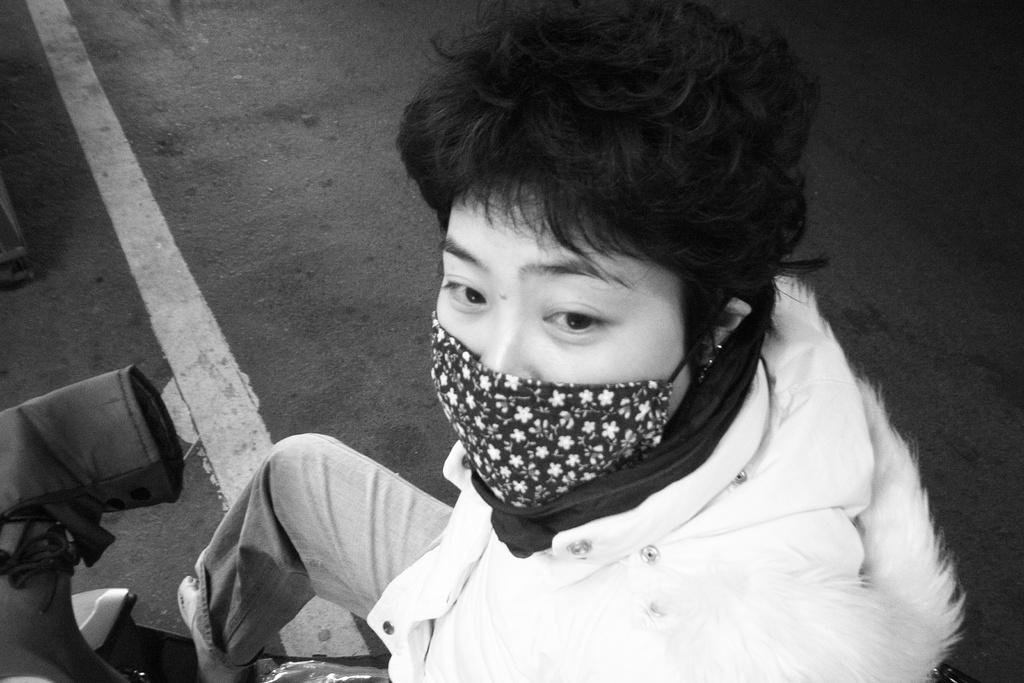Could you give a brief overview of what you see in this image? In this image we can see a person wearing a nose mask. 